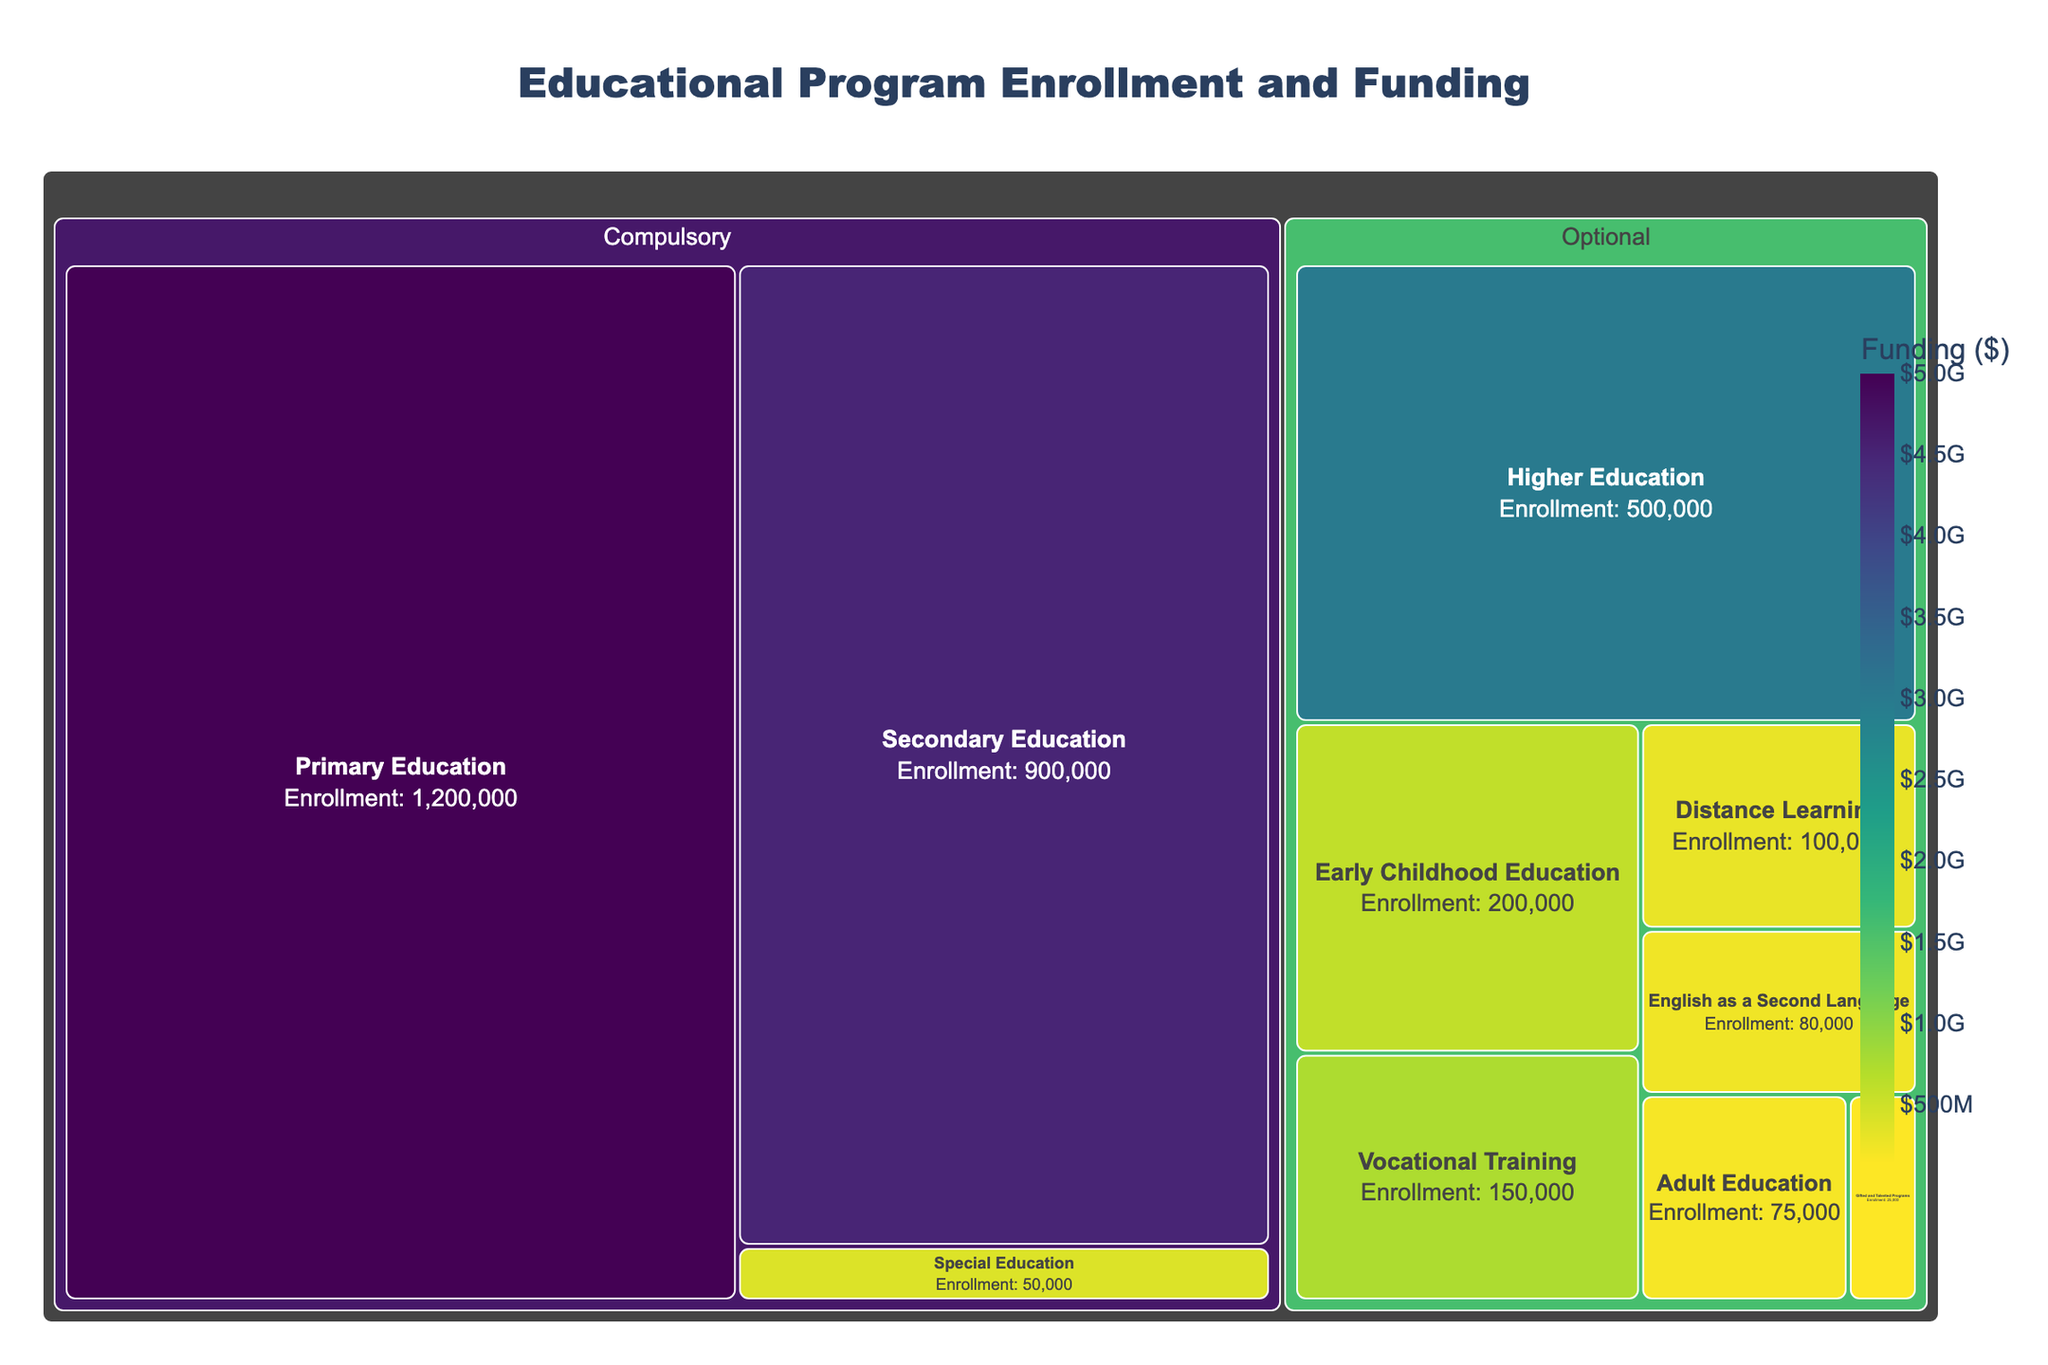What is the title of the Treemap? At the top of the Treemap, there's a textual element that indicates the main subject of the figure. The title reads "Educational Program Enrollment and Funding."
Answer: Educational Program Enrollment and Funding Which educational program has the highest enrollment? By inspecting the size of the rectangles, the largest one represents the program with the highest enrollment. The "Primary Education" program occupies the largest area in the Treemap.
Answer: Primary Education How much funding does Secondary Education receive? Hovering over the rectangle for Secondary Education reveals its funding information. The funding for Secondary Education is $4,500,000,000.
Answer: $4,500,000,000 What’s the total enrollment for all Compulsory programs? Add the enrollment numbers for all programs under the "Compulsory" category: Primary Education (1,200,000), Secondary Education (900,000), and Special Education (50,000). The total is 1,200,000 + 900,000 + 50,000 = 2,150,000.
Answer: 2,150,000 Which category has higher total funding: Compulsory or Optional? Sum the funding amounts for each category and compare: 
- Compulsory: Primary ($5,000,000,000) + Secondary ($4,500,000,000) + Special ($400,000,000) = $9,900,000,000 
- Optional: Vocational ($750,000,000) + Higher ($3,000,000,000) + Adult ($200,000,000) + Early Childhood ($600,000,000) + Distance ($300,000,000) + Gifted ($150,000,000) + ESL ($250,000,000) = $5,250,000,000.
Compulsory category has higher total funding.
Answer: Compulsory How does the funding for Vocational Training compare to Higher Education? The funding is displayed when you hover over the rectangles. Vocational Training receives $750,000,000, while Higher Education receives $3,000,000,000. Vocational Training has significantly less funding than Higher Education.
Answer: Vocational Training has less funding Which educational program under the Optional category has the lowest enrollment? Within the Optional category, the smallest rectangle will indicate the program with the lowest enrollment. "Gifted and Talented Programs" has the smallest area.
Answer: Gifted and Talented Programs What is the relationship between enrollment and funding in the Treemap? Observing the Treemap, larger enrollments don't always correlate with higher funding. For instance, Primary Education has the highest enrollment and funding, but Vocational Training has moderate enrollment yet significantly less funding. This suggests funding varies independently of enrollment.
Answer: Funding varies independently of enrollment What is the average enrollment for the programs listed? Calculate the total enrollment of all programs and divide by the number of programs:
(1,200,000 + 900,000 + 150,000 + 500,000 + 50,000 + 75,000 + 200,000 + 100,000 + 25,000 + 80,000) / 10 = 3,280,000 / 10 = 328,000.
Answer: 328,000 